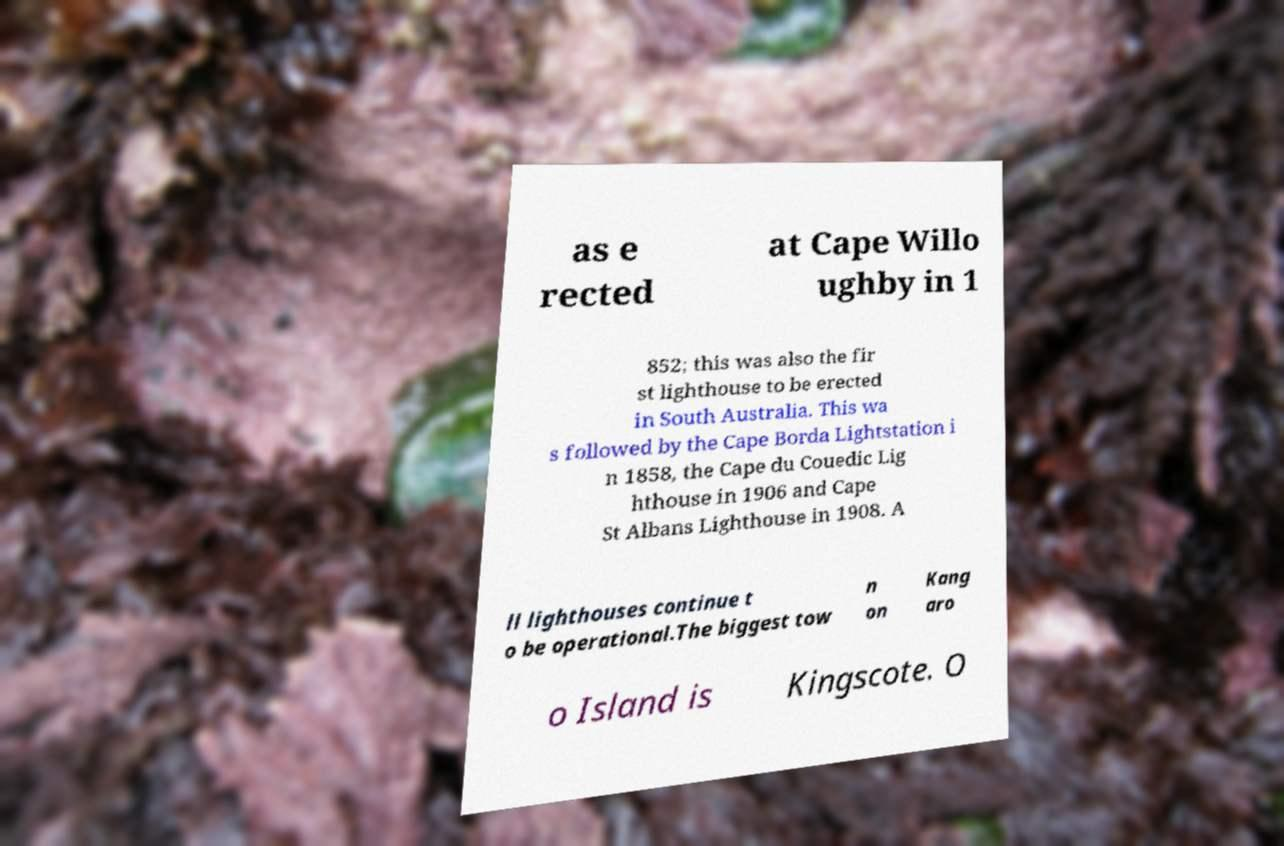Can you read and provide the text displayed in the image?This photo seems to have some interesting text. Can you extract and type it out for me? as e rected at Cape Willo ughby in 1 852; this was also the fir st lighthouse to be erected in South Australia. This wa s followed by the Cape Borda Lightstation i n 1858, the Cape du Couedic Lig hthouse in 1906 and Cape St Albans Lighthouse in 1908. A ll lighthouses continue t o be operational.The biggest tow n on Kang aro o Island is Kingscote. O 